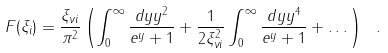Convert formula to latex. <formula><loc_0><loc_0><loc_500><loc_500>F ( \xi _ { i } ) = \frac { \xi _ { \nu i } } { \pi ^ { 2 } } \left ( \int _ { 0 } ^ { \infty } \frac { d y y ^ { 2 } } { e ^ { y } + 1 } + \frac { 1 } { 2 \xi _ { \nu i } ^ { 2 } } \int _ { 0 } ^ { \infty } \frac { d y y ^ { 4 } } { e ^ { y } + 1 } + \dots \right ) \ .</formula> 